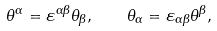Convert formula to latex. <formula><loc_0><loc_0><loc_500><loc_500>\theta ^ { \alpha } = \varepsilon ^ { \alpha \beta } \theta _ { \beta } , \quad \theta _ { \alpha } = \varepsilon _ { \alpha \beta } \theta ^ { \beta } ,</formula> 